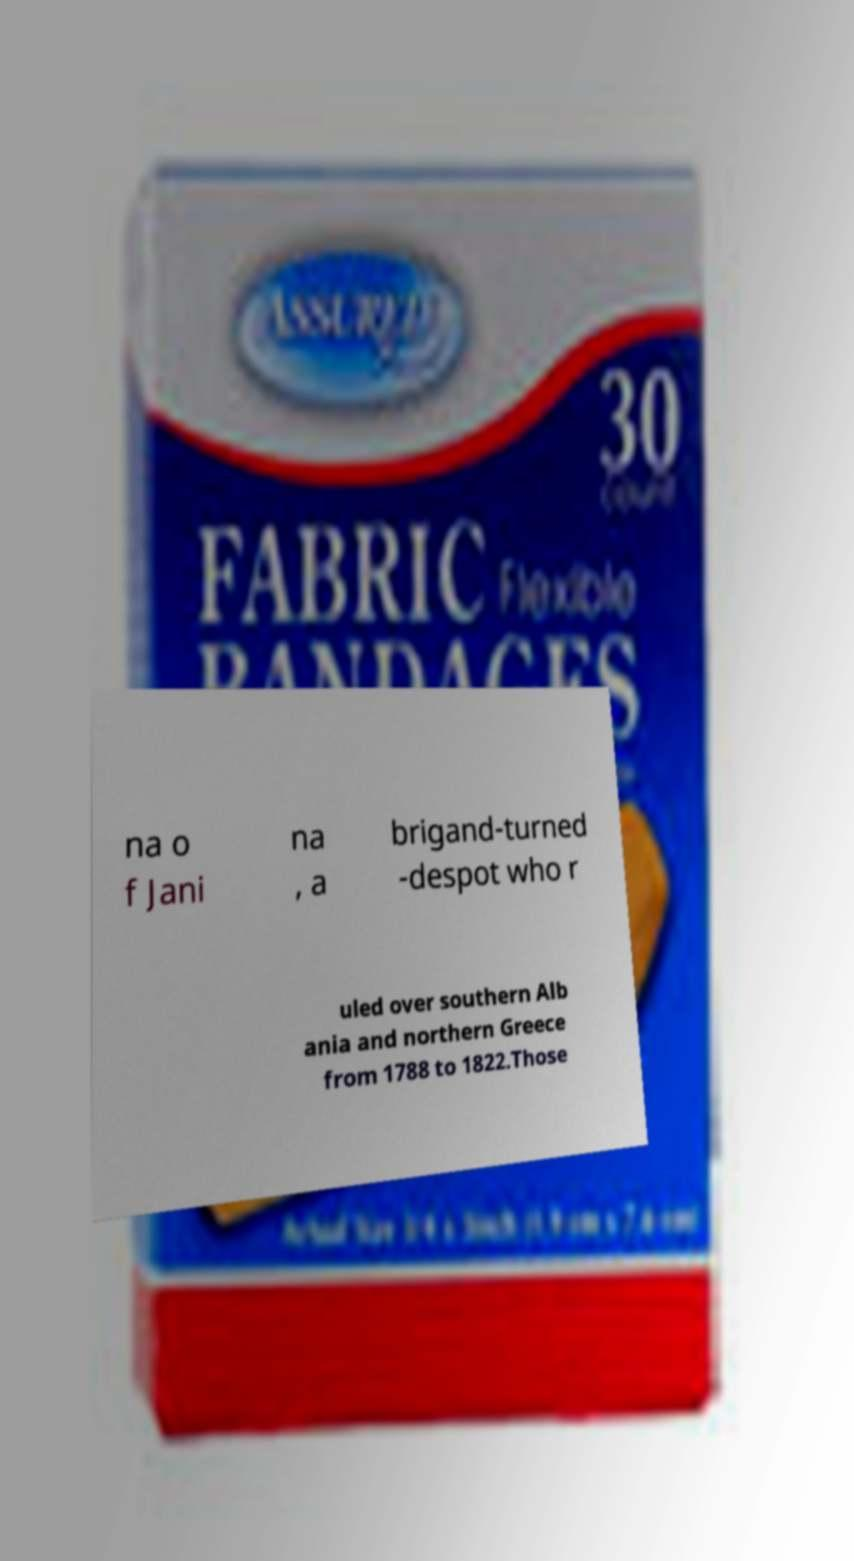I need the written content from this picture converted into text. Can you do that? na o f Jani na , a brigand-turned -despot who r uled over southern Alb ania and northern Greece from 1788 to 1822.Those 